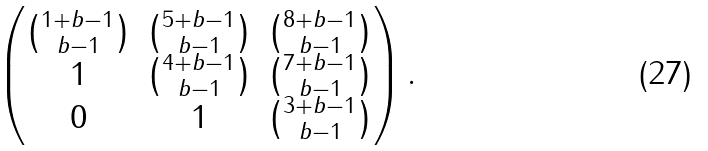Convert formula to latex. <formula><loc_0><loc_0><loc_500><loc_500>\begin{pmatrix} \binom { 1 + b - 1 } { b - 1 } & \binom { 5 + b - 1 } { b - 1 } & \binom { 8 + b - 1 } { b - 1 } \\ 1 & \binom { 4 + b - 1 } { b - 1 } & \binom { 7 + b - 1 } { b - 1 } \\ 0 & 1 & \binom { 3 + b - 1 } { b - 1 } \end{pmatrix} .</formula> 